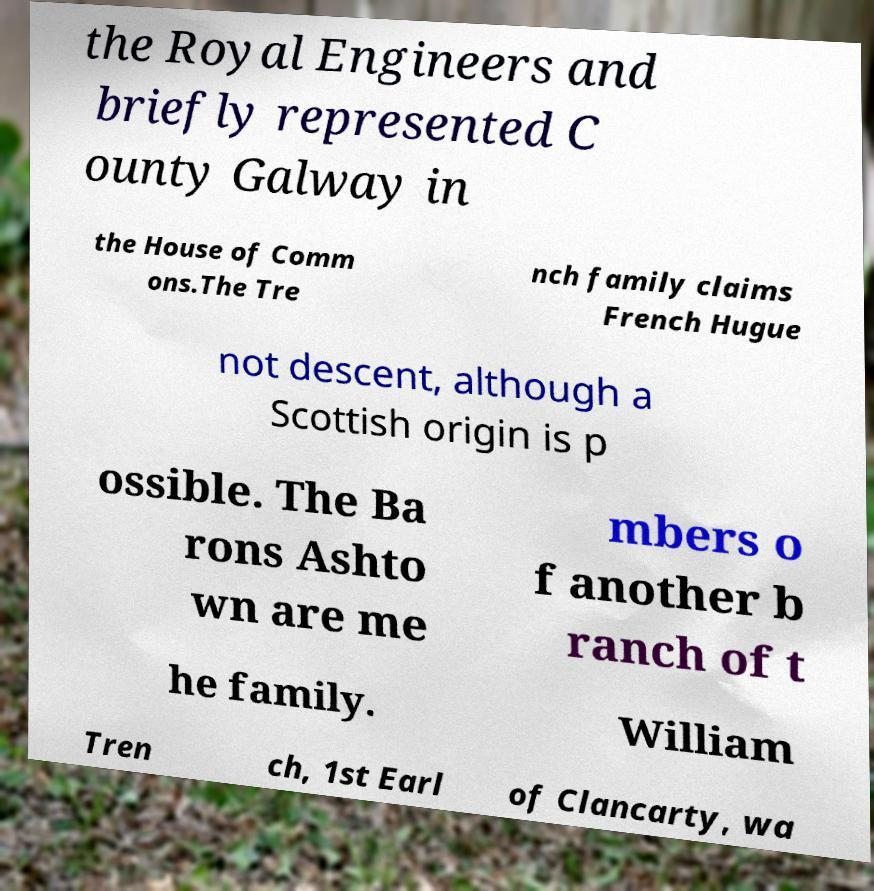Please identify and transcribe the text found in this image. the Royal Engineers and briefly represented C ounty Galway in the House of Comm ons.The Tre nch family claims French Hugue not descent, although a Scottish origin is p ossible. The Ba rons Ashto wn are me mbers o f another b ranch of t he family. William Tren ch, 1st Earl of Clancarty, wa 